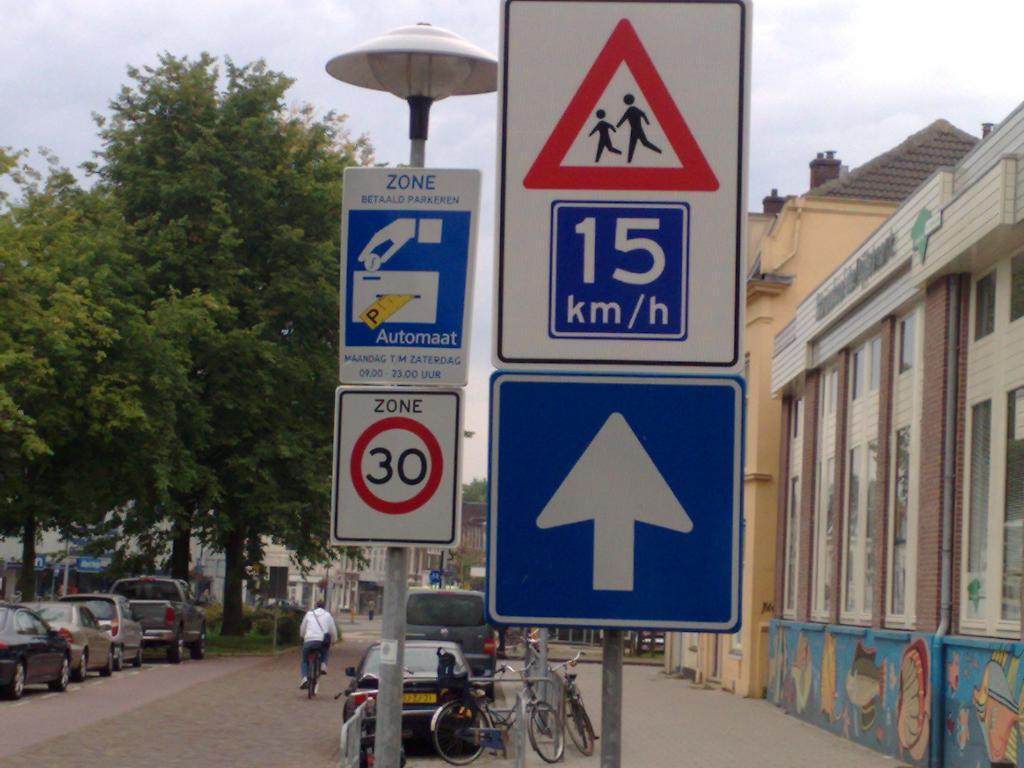What is written at the top of the sign to the left?
Keep it short and to the point. Zone. 